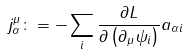<formula> <loc_0><loc_0><loc_500><loc_500>j _ { \alpha } ^ { \mu } \colon = - \sum _ { i } \frac { \partial L } { \partial \left ( \partial _ { \mu } \psi _ { i } \right ) } a _ { \alpha i }</formula> 